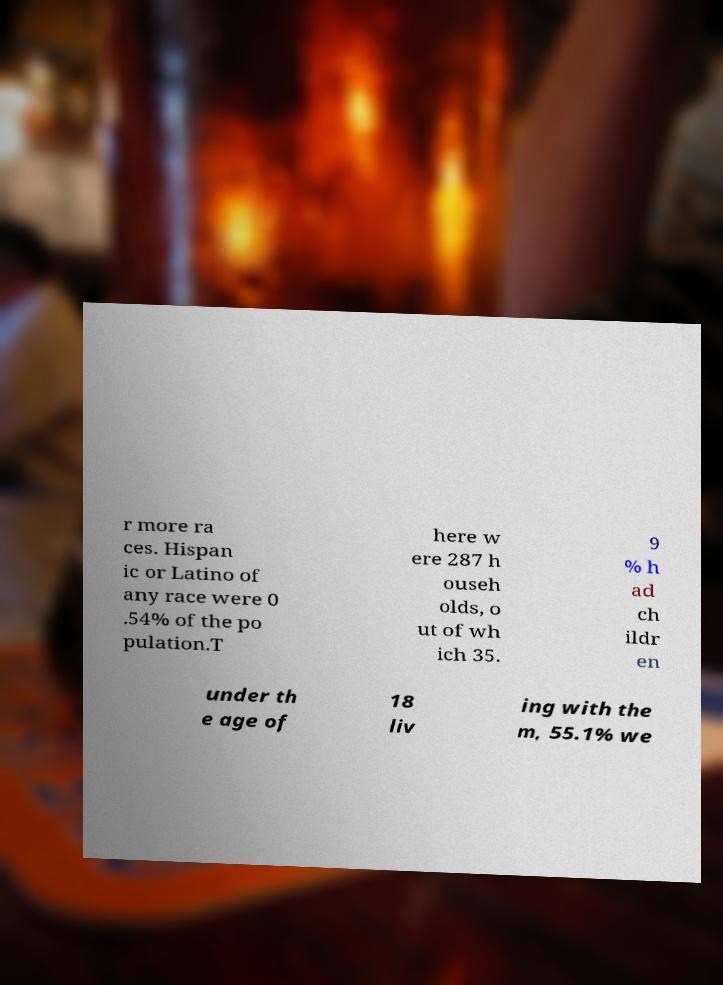For documentation purposes, I need the text within this image transcribed. Could you provide that? r more ra ces. Hispan ic or Latino of any race were 0 .54% of the po pulation.T here w ere 287 h ouseh olds, o ut of wh ich 35. 9 % h ad ch ildr en under th e age of 18 liv ing with the m, 55.1% we 